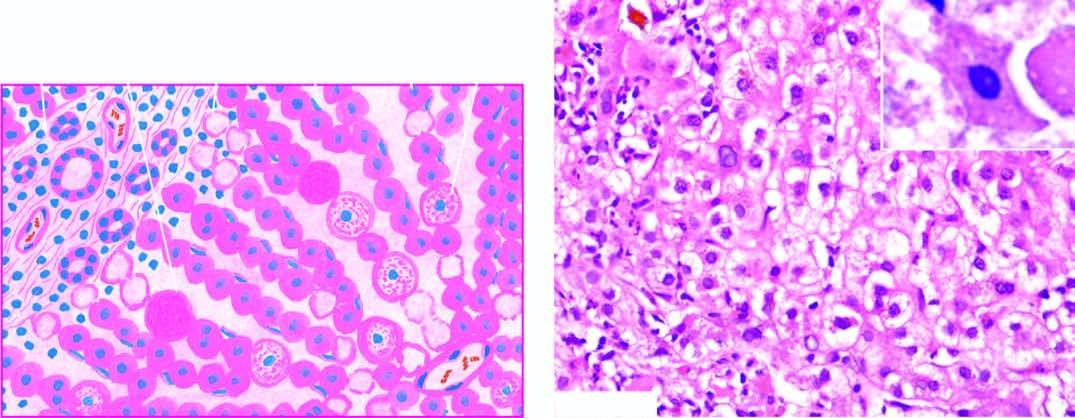what are the predominant histologic changes?
Answer the question using a single word or phrase. Variable degree of necrosis of hepatocytes 